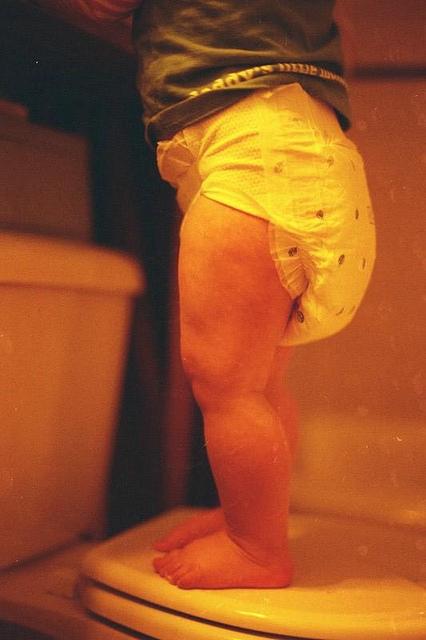What is the baby on?
Short answer required. Toilet. What pattern is on the baby's diaper?
Answer briefly. Dots. Are these the legs of an old person?
Short answer required. No. 